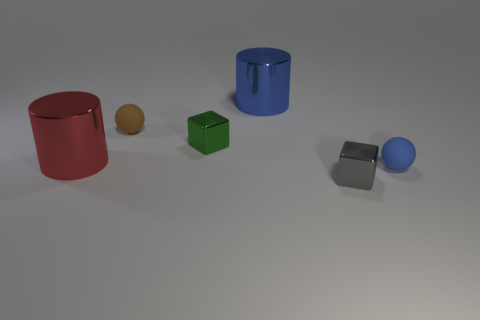Add 2 brown rubber cylinders. How many objects exist? 8 Subtract all cylinders. How many objects are left? 4 Subtract all tiny shiny cylinders. Subtract all large cylinders. How many objects are left? 4 Add 1 large shiny cylinders. How many large shiny cylinders are left? 3 Add 2 gray rubber things. How many gray rubber things exist? 2 Subtract 0 red blocks. How many objects are left? 6 